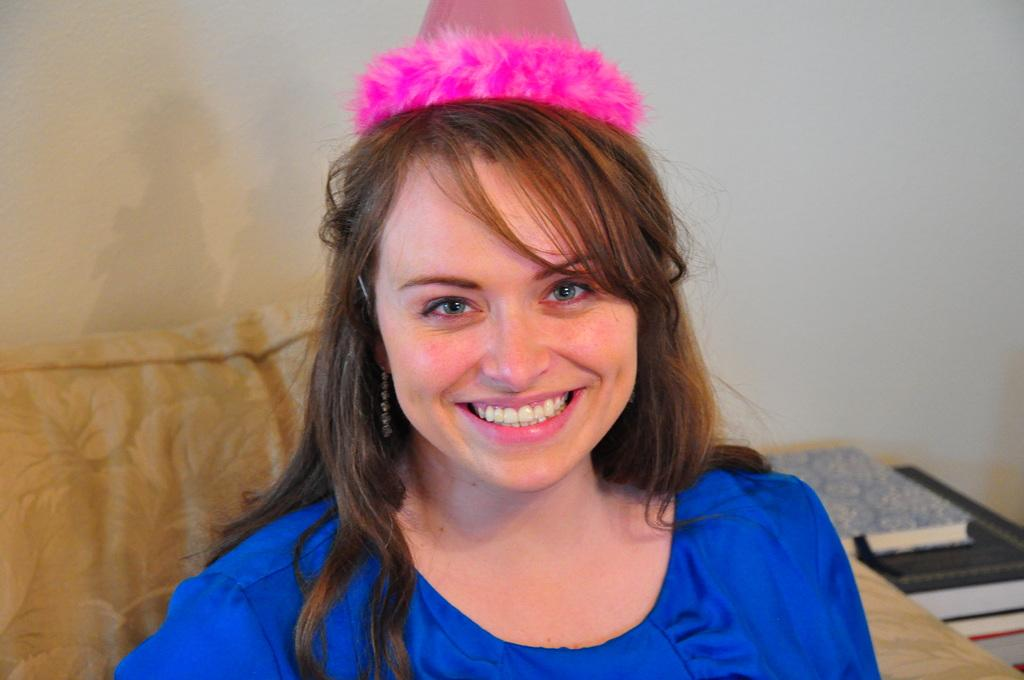What is the main subject of the image? There is a person in the image. What is the person wearing? The person is wearing a blue dress and a pink cap on her head. What is the person doing in the image? The person is sitting on a sofa. Where is the sofa located in the image? There is a sofa on the right side of the image. What is the beggar asking for in the image? There is no beggar present in the image. Who is the owner of the sofa in the image? The image does not provide information about the ownership of the sofa. 